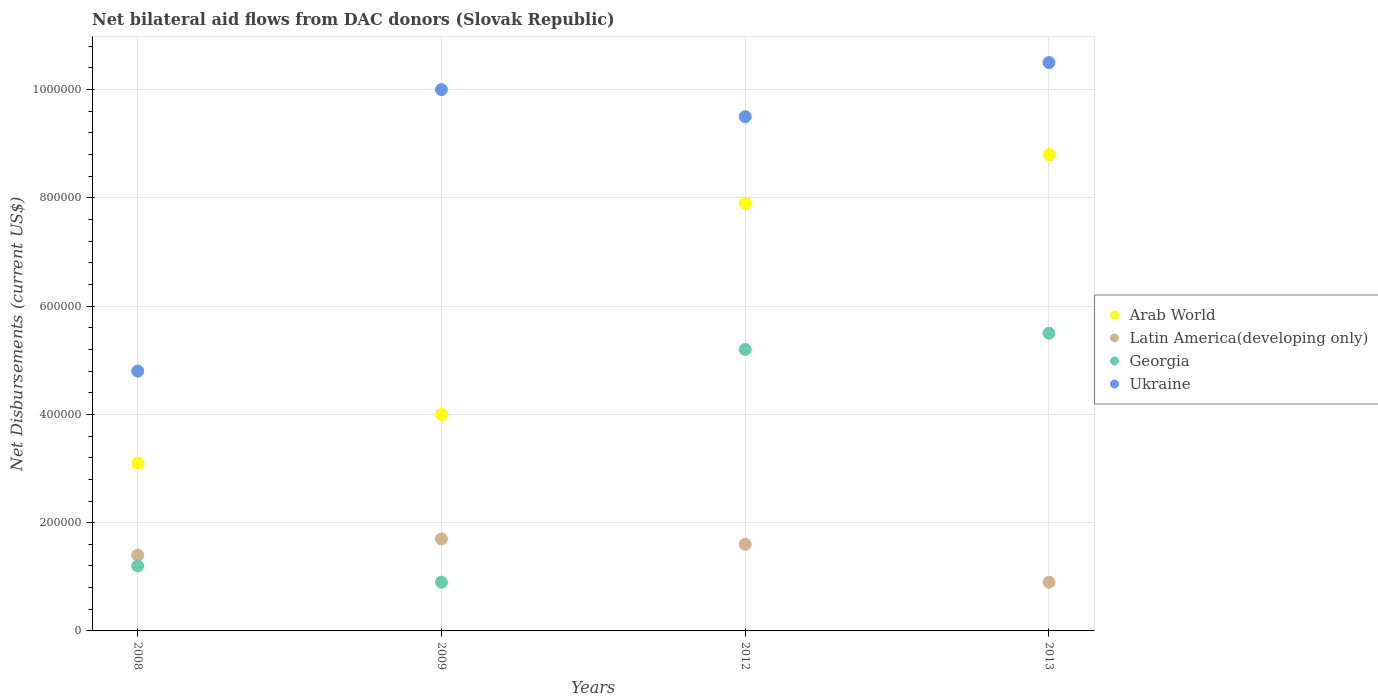Is the number of dotlines equal to the number of legend labels?
Your answer should be compact. Yes. Across all years, what is the maximum net bilateral aid flows in Arab World?
Provide a short and direct response. 8.80e+05. In which year was the net bilateral aid flows in Ukraine maximum?
Offer a very short reply. 2013. In which year was the net bilateral aid flows in Latin America(developing only) minimum?
Give a very brief answer. 2013. What is the total net bilateral aid flows in Latin America(developing only) in the graph?
Your response must be concise. 5.60e+05. What is the difference between the net bilateral aid flows in Latin America(developing only) in 2009 and that in 2012?
Provide a short and direct response. 10000. What is the difference between the net bilateral aid flows in Georgia in 2009 and the net bilateral aid flows in Arab World in 2008?
Ensure brevity in your answer.  -2.20e+05. What is the average net bilateral aid flows in Ukraine per year?
Your response must be concise. 8.70e+05. Is the net bilateral aid flows in Latin America(developing only) in 2008 less than that in 2009?
Offer a very short reply. Yes. What is the difference between the highest and the second highest net bilateral aid flows in Georgia?
Your answer should be very brief. 3.00e+04. What is the difference between the highest and the lowest net bilateral aid flows in Arab World?
Your answer should be very brief. 5.70e+05. Is it the case that in every year, the sum of the net bilateral aid flows in Georgia and net bilateral aid flows in Arab World  is greater than the sum of net bilateral aid flows in Ukraine and net bilateral aid flows in Latin America(developing only)?
Offer a very short reply. Yes. Is it the case that in every year, the sum of the net bilateral aid flows in Georgia and net bilateral aid flows in Arab World  is greater than the net bilateral aid flows in Latin America(developing only)?
Your answer should be compact. Yes. Does the net bilateral aid flows in Arab World monotonically increase over the years?
Your answer should be very brief. Yes. Is the net bilateral aid flows in Ukraine strictly less than the net bilateral aid flows in Arab World over the years?
Offer a very short reply. No. How many dotlines are there?
Ensure brevity in your answer.  4. Are the values on the major ticks of Y-axis written in scientific E-notation?
Keep it short and to the point. No. Does the graph contain any zero values?
Offer a very short reply. No. Does the graph contain grids?
Offer a terse response. Yes. What is the title of the graph?
Offer a terse response. Net bilateral aid flows from DAC donors (Slovak Republic). Does "Botswana" appear as one of the legend labels in the graph?
Give a very brief answer. No. What is the label or title of the Y-axis?
Keep it short and to the point. Net Disbursements (current US$). What is the Net Disbursements (current US$) of Georgia in 2008?
Ensure brevity in your answer.  1.20e+05. What is the Net Disbursements (current US$) in Arab World in 2009?
Your response must be concise. 4.00e+05. What is the Net Disbursements (current US$) of Georgia in 2009?
Your answer should be very brief. 9.00e+04. What is the Net Disbursements (current US$) of Ukraine in 2009?
Keep it short and to the point. 1.00e+06. What is the Net Disbursements (current US$) in Arab World in 2012?
Provide a succinct answer. 7.90e+05. What is the Net Disbursements (current US$) in Georgia in 2012?
Offer a very short reply. 5.20e+05. What is the Net Disbursements (current US$) of Ukraine in 2012?
Your response must be concise. 9.50e+05. What is the Net Disbursements (current US$) in Arab World in 2013?
Offer a terse response. 8.80e+05. What is the Net Disbursements (current US$) in Latin America(developing only) in 2013?
Provide a succinct answer. 9.00e+04. What is the Net Disbursements (current US$) of Georgia in 2013?
Keep it short and to the point. 5.50e+05. What is the Net Disbursements (current US$) of Ukraine in 2013?
Ensure brevity in your answer.  1.05e+06. Across all years, what is the maximum Net Disbursements (current US$) of Arab World?
Your answer should be compact. 8.80e+05. Across all years, what is the maximum Net Disbursements (current US$) in Latin America(developing only)?
Provide a succinct answer. 1.70e+05. Across all years, what is the maximum Net Disbursements (current US$) of Ukraine?
Provide a succinct answer. 1.05e+06. Across all years, what is the minimum Net Disbursements (current US$) in Arab World?
Offer a very short reply. 3.10e+05. Across all years, what is the minimum Net Disbursements (current US$) of Ukraine?
Give a very brief answer. 4.80e+05. What is the total Net Disbursements (current US$) of Arab World in the graph?
Offer a very short reply. 2.38e+06. What is the total Net Disbursements (current US$) of Latin America(developing only) in the graph?
Offer a very short reply. 5.60e+05. What is the total Net Disbursements (current US$) in Georgia in the graph?
Provide a short and direct response. 1.28e+06. What is the total Net Disbursements (current US$) of Ukraine in the graph?
Give a very brief answer. 3.48e+06. What is the difference between the Net Disbursements (current US$) of Ukraine in 2008 and that in 2009?
Your response must be concise. -5.20e+05. What is the difference between the Net Disbursements (current US$) in Arab World in 2008 and that in 2012?
Keep it short and to the point. -4.80e+05. What is the difference between the Net Disbursements (current US$) of Latin America(developing only) in 2008 and that in 2012?
Offer a very short reply. -2.00e+04. What is the difference between the Net Disbursements (current US$) in Georgia in 2008 and that in 2012?
Provide a succinct answer. -4.00e+05. What is the difference between the Net Disbursements (current US$) in Ukraine in 2008 and that in 2012?
Your response must be concise. -4.70e+05. What is the difference between the Net Disbursements (current US$) in Arab World in 2008 and that in 2013?
Give a very brief answer. -5.70e+05. What is the difference between the Net Disbursements (current US$) of Georgia in 2008 and that in 2013?
Provide a succinct answer. -4.30e+05. What is the difference between the Net Disbursements (current US$) in Ukraine in 2008 and that in 2013?
Your answer should be very brief. -5.70e+05. What is the difference between the Net Disbursements (current US$) in Arab World in 2009 and that in 2012?
Offer a terse response. -3.90e+05. What is the difference between the Net Disbursements (current US$) of Georgia in 2009 and that in 2012?
Make the answer very short. -4.30e+05. What is the difference between the Net Disbursements (current US$) of Ukraine in 2009 and that in 2012?
Provide a short and direct response. 5.00e+04. What is the difference between the Net Disbursements (current US$) of Arab World in 2009 and that in 2013?
Your answer should be very brief. -4.80e+05. What is the difference between the Net Disbursements (current US$) in Latin America(developing only) in 2009 and that in 2013?
Offer a very short reply. 8.00e+04. What is the difference between the Net Disbursements (current US$) of Georgia in 2009 and that in 2013?
Give a very brief answer. -4.60e+05. What is the difference between the Net Disbursements (current US$) in Arab World in 2012 and that in 2013?
Keep it short and to the point. -9.00e+04. What is the difference between the Net Disbursements (current US$) of Arab World in 2008 and the Net Disbursements (current US$) of Latin America(developing only) in 2009?
Give a very brief answer. 1.40e+05. What is the difference between the Net Disbursements (current US$) in Arab World in 2008 and the Net Disbursements (current US$) in Georgia in 2009?
Ensure brevity in your answer.  2.20e+05. What is the difference between the Net Disbursements (current US$) of Arab World in 2008 and the Net Disbursements (current US$) of Ukraine in 2009?
Your answer should be compact. -6.90e+05. What is the difference between the Net Disbursements (current US$) of Latin America(developing only) in 2008 and the Net Disbursements (current US$) of Ukraine in 2009?
Your answer should be compact. -8.60e+05. What is the difference between the Net Disbursements (current US$) of Georgia in 2008 and the Net Disbursements (current US$) of Ukraine in 2009?
Ensure brevity in your answer.  -8.80e+05. What is the difference between the Net Disbursements (current US$) of Arab World in 2008 and the Net Disbursements (current US$) of Latin America(developing only) in 2012?
Offer a very short reply. 1.50e+05. What is the difference between the Net Disbursements (current US$) in Arab World in 2008 and the Net Disbursements (current US$) in Ukraine in 2012?
Offer a terse response. -6.40e+05. What is the difference between the Net Disbursements (current US$) of Latin America(developing only) in 2008 and the Net Disbursements (current US$) of Georgia in 2012?
Offer a terse response. -3.80e+05. What is the difference between the Net Disbursements (current US$) in Latin America(developing only) in 2008 and the Net Disbursements (current US$) in Ukraine in 2012?
Your answer should be compact. -8.10e+05. What is the difference between the Net Disbursements (current US$) of Georgia in 2008 and the Net Disbursements (current US$) of Ukraine in 2012?
Your answer should be very brief. -8.30e+05. What is the difference between the Net Disbursements (current US$) in Arab World in 2008 and the Net Disbursements (current US$) in Latin America(developing only) in 2013?
Make the answer very short. 2.20e+05. What is the difference between the Net Disbursements (current US$) in Arab World in 2008 and the Net Disbursements (current US$) in Ukraine in 2013?
Your response must be concise. -7.40e+05. What is the difference between the Net Disbursements (current US$) of Latin America(developing only) in 2008 and the Net Disbursements (current US$) of Georgia in 2013?
Offer a terse response. -4.10e+05. What is the difference between the Net Disbursements (current US$) in Latin America(developing only) in 2008 and the Net Disbursements (current US$) in Ukraine in 2013?
Offer a very short reply. -9.10e+05. What is the difference between the Net Disbursements (current US$) in Georgia in 2008 and the Net Disbursements (current US$) in Ukraine in 2013?
Provide a succinct answer. -9.30e+05. What is the difference between the Net Disbursements (current US$) of Arab World in 2009 and the Net Disbursements (current US$) of Ukraine in 2012?
Keep it short and to the point. -5.50e+05. What is the difference between the Net Disbursements (current US$) of Latin America(developing only) in 2009 and the Net Disbursements (current US$) of Georgia in 2012?
Your answer should be very brief. -3.50e+05. What is the difference between the Net Disbursements (current US$) in Latin America(developing only) in 2009 and the Net Disbursements (current US$) in Ukraine in 2012?
Offer a terse response. -7.80e+05. What is the difference between the Net Disbursements (current US$) of Georgia in 2009 and the Net Disbursements (current US$) of Ukraine in 2012?
Ensure brevity in your answer.  -8.60e+05. What is the difference between the Net Disbursements (current US$) of Arab World in 2009 and the Net Disbursements (current US$) of Ukraine in 2013?
Provide a short and direct response. -6.50e+05. What is the difference between the Net Disbursements (current US$) in Latin America(developing only) in 2009 and the Net Disbursements (current US$) in Georgia in 2013?
Ensure brevity in your answer.  -3.80e+05. What is the difference between the Net Disbursements (current US$) in Latin America(developing only) in 2009 and the Net Disbursements (current US$) in Ukraine in 2013?
Offer a very short reply. -8.80e+05. What is the difference between the Net Disbursements (current US$) in Georgia in 2009 and the Net Disbursements (current US$) in Ukraine in 2013?
Provide a succinct answer. -9.60e+05. What is the difference between the Net Disbursements (current US$) of Arab World in 2012 and the Net Disbursements (current US$) of Latin America(developing only) in 2013?
Your answer should be very brief. 7.00e+05. What is the difference between the Net Disbursements (current US$) of Latin America(developing only) in 2012 and the Net Disbursements (current US$) of Georgia in 2013?
Ensure brevity in your answer.  -3.90e+05. What is the difference between the Net Disbursements (current US$) of Latin America(developing only) in 2012 and the Net Disbursements (current US$) of Ukraine in 2013?
Offer a terse response. -8.90e+05. What is the difference between the Net Disbursements (current US$) in Georgia in 2012 and the Net Disbursements (current US$) in Ukraine in 2013?
Offer a very short reply. -5.30e+05. What is the average Net Disbursements (current US$) of Arab World per year?
Your answer should be compact. 5.95e+05. What is the average Net Disbursements (current US$) of Latin America(developing only) per year?
Your answer should be compact. 1.40e+05. What is the average Net Disbursements (current US$) of Georgia per year?
Make the answer very short. 3.20e+05. What is the average Net Disbursements (current US$) of Ukraine per year?
Provide a short and direct response. 8.70e+05. In the year 2008, what is the difference between the Net Disbursements (current US$) in Arab World and Net Disbursements (current US$) in Latin America(developing only)?
Ensure brevity in your answer.  1.70e+05. In the year 2008, what is the difference between the Net Disbursements (current US$) in Latin America(developing only) and Net Disbursements (current US$) in Georgia?
Ensure brevity in your answer.  2.00e+04. In the year 2008, what is the difference between the Net Disbursements (current US$) of Latin America(developing only) and Net Disbursements (current US$) of Ukraine?
Your answer should be compact. -3.40e+05. In the year 2008, what is the difference between the Net Disbursements (current US$) in Georgia and Net Disbursements (current US$) in Ukraine?
Keep it short and to the point. -3.60e+05. In the year 2009, what is the difference between the Net Disbursements (current US$) in Arab World and Net Disbursements (current US$) in Latin America(developing only)?
Provide a succinct answer. 2.30e+05. In the year 2009, what is the difference between the Net Disbursements (current US$) in Arab World and Net Disbursements (current US$) in Georgia?
Provide a short and direct response. 3.10e+05. In the year 2009, what is the difference between the Net Disbursements (current US$) of Arab World and Net Disbursements (current US$) of Ukraine?
Keep it short and to the point. -6.00e+05. In the year 2009, what is the difference between the Net Disbursements (current US$) in Latin America(developing only) and Net Disbursements (current US$) in Ukraine?
Make the answer very short. -8.30e+05. In the year 2009, what is the difference between the Net Disbursements (current US$) of Georgia and Net Disbursements (current US$) of Ukraine?
Ensure brevity in your answer.  -9.10e+05. In the year 2012, what is the difference between the Net Disbursements (current US$) of Arab World and Net Disbursements (current US$) of Latin America(developing only)?
Offer a terse response. 6.30e+05. In the year 2012, what is the difference between the Net Disbursements (current US$) in Arab World and Net Disbursements (current US$) in Georgia?
Your answer should be very brief. 2.70e+05. In the year 2012, what is the difference between the Net Disbursements (current US$) in Latin America(developing only) and Net Disbursements (current US$) in Georgia?
Your answer should be very brief. -3.60e+05. In the year 2012, what is the difference between the Net Disbursements (current US$) in Latin America(developing only) and Net Disbursements (current US$) in Ukraine?
Your answer should be compact. -7.90e+05. In the year 2012, what is the difference between the Net Disbursements (current US$) in Georgia and Net Disbursements (current US$) in Ukraine?
Give a very brief answer. -4.30e+05. In the year 2013, what is the difference between the Net Disbursements (current US$) in Arab World and Net Disbursements (current US$) in Latin America(developing only)?
Keep it short and to the point. 7.90e+05. In the year 2013, what is the difference between the Net Disbursements (current US$) of Latin America(developing only) and Net Disbursements (current US$) of Georgia?
Your response must be concise. -4.60e+05. In the year 2013, what is the difference between the Net Disbursements (current US$) in Latin America(developing only) and Net Disbursements (current US$) in Ukraine?
Offer a very short reply. -9.60e+05. In the year 2013, what is the difference between the Net Disbursements (current US$) in Georgia and Net Disbursements (current US$) in Ukraine?
Your response must be concise. -5.00e+05. What is the ratio of the Net Disbursements (current US$) of Arab World in 2008 to that in 2009?
Make the answer very short. 0.78. What is the ratio of the Net Disbursements (current US$) of Latin America(developing only) in 2008 to that in 2009?
Provide a short and direct response. 0.82. What is the ratio of the Net Disbursements (current US$) of Ukraine in 2008 to that in 2009?
Make the answer very short. 0.48. What is the ratio of the Net Disbursements (current US$) of Arab World in 2008 to that in 2012?
Your answer should be compact. 0.39. What is the ratio of the Net Disbursements (current US$) of Georgia in 2008 to that in 2012?
Keep it short and to the point. 0.23. What is the ratio of the Net Disbursements (current US$) of Ukraine in 2008 to that in 2012?
Ensure brevity in your answer.  0.51. What is the ratio of the Net Disbursements (current US$) in Arab World in 2008 to that in 2013?
Your answer should be compact. 0.35. What is the ratio of the Net Disbursements (current US$) in Latin America(developing only) in 2008 to that in 2013?
Your answer should be very brief. 1.56. What is the ratio of the Net Disbursements (current US$) in Georgia in 2008 to that in 2013?
Offer a terse response. 0.22. What is the ratio of the Net Disbursements (current US$) of Ukraine in 2008 to that in 2013?
Provide a short and direct response. 0.46. What is the ratio of the Net Disbursements (current US$) of Arab World in 2009 to that in 2012?
Provide a short and direct response. 0.51. What is the ratio of the Net Disbursements (current US$) in Georgia in 2009 to that in 2012?
Provide a succinct answer. 0.17. What is the ratio of the Net Disbursements (current US$) of Ukraine in 2009 to that in 2012?
Your response must be concise. 1.05. What is the ratio of the Net Disbursements (current US$) of Arab World in 2009 to that in 2013?
Your answer should be very brief. 0.45. What is the ratio of the Net Disbursements (current US$) in Latin America(developing only) in 2009 to that in 2013?
Offer a terse response. 1.89. What is the ratio of the Net Disbursements (current US$) in Georgia in 2009 to that in 2013?
Offer a very short reply. 0.16. What is the ratio of the Net Disbursements (current US$) in Ukraine in 2009 to that in 2013?
Make the answer very short. 0.95. What is the ratio of the Net Disbursements (current US$) in Arab World in 2012 to that in 2013?
Offer a very short reply. 0.9. What is the ratio of the Net Disbursements (current US$) in Latin America(developing only) in 2012 to that in 2013?
Your answer should be very brief. 1.78. What is the ratio of the Net Disbursements (current US$) of Georgia in 2012 to that in 2013?
Your answer should be very brief. 0.95. What is the ratio of the Net Disbursements (current US$) of Ukraine in 2012 to that in 2013?
Ensure brevity in your answer.  0.9. What is the difference between the highest and the second highest Net Disbursements (current US$) in Georgia?
Offer a terse response. 3.00e+04. What is the difference between the highest and the second highest Net Disbursements (current US$) of Ukraine?
Provide a succinct answer. 5.00e+04. What is the difference between the highest and the lowest Net Disbursements (current US$) in Arab World?
Ensure brevity in your answer.  5.70e+05. What is the difference between the highest and the lowest Net Disbursements (current US$) of Latin America(developing only)?
Offer a very short reply. 8.00e+04. What is the difference between the highest and the lowest Net Disbursements (current US$) of Georgia?
Offer a very short reply. 4.60e+05. What is the difference between the highest and the lowest Net Disbursements (current US$) in Ukraine?
Offer a terse response. 5.70e+05. 